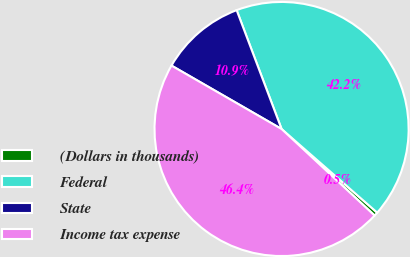Convert chart to OTSL. <chart><loc_0><loc_0><loc_500><loc_500><pie_chart><fcel>(Dollars in thousands)<fcel>Federal<fcel>State<fcel>Income tax expense<nl><fcel>0.49%<fcel>42.19%<fcel>10.93%<fcel>46.39%<nl></chart> 